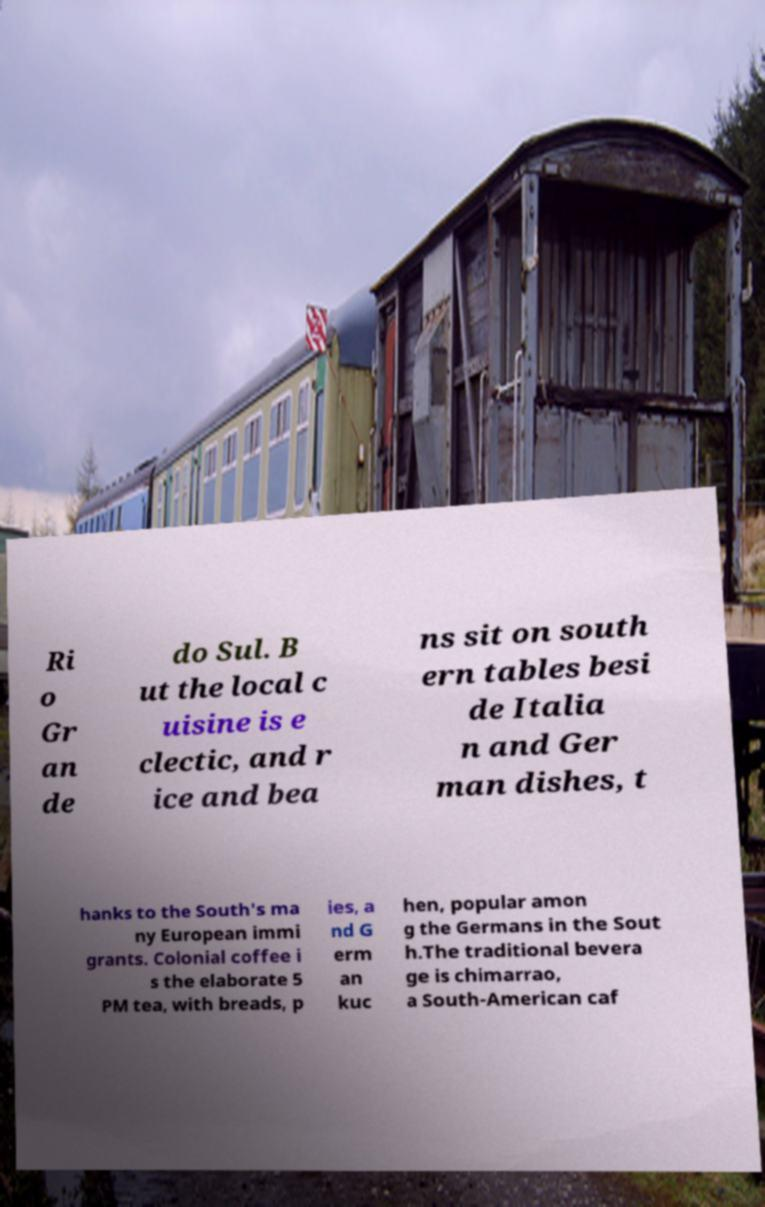Can you read and provide the text displayed in the image?This photo seems to have some interesting text. Can you extract and type it out for me? Ri o Gr an de do Sul. B ut the local c uisine is e clectic, and r ice and bea ns sit on south ern tables besi de Italia n and Ger man dishes, t hanks to the South's ma ny European immi grants. Colonial coffee i s the elaborate 5 PM tea, with breads, p ies, a nd G erm an kuc hen, popular amon g the Germans in the Sout h.The traditional bevera ge is chimarrao, a South-American caf 